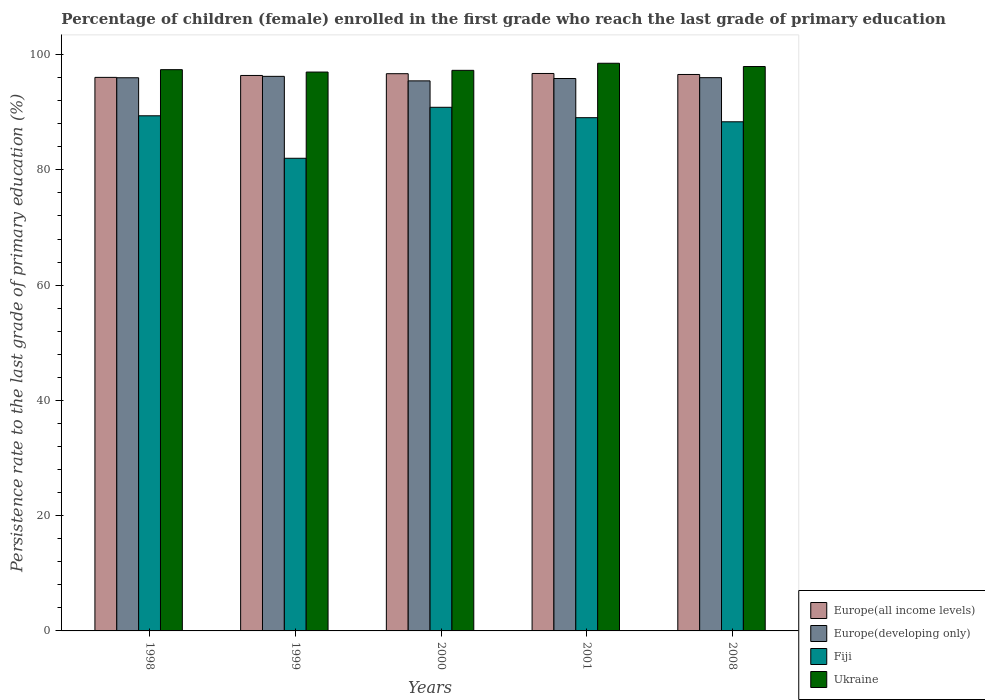Are the number of bars on each tick of the X-axis equal?
Your answer should be very brief. Yes. How many bars are there on the 1st tick from the left?
Provide a succinct answer. 4. What is the label of the 2nd group of bars from the left?
Provide a succinct answer. 1999. In how many cases, is the number of bars for a given year not equal to the number of legend labels?
Provide a short and direct response. 0. What is the persistence rate of children in Europe(all income levels) in 1998?
Offer a terse response. 96.04. Across all years, what is the maximum persistence rate of children in Ukraine?
Make the answer very short. 98.49. Across all years, what is the minimum persistence rate of children in Fiji?
Offer a terse response. 82.01. What is the total persistence rate of children in Europe(developing only) in the graph?
Ensure brevity in your answer.  479.48. What is the difference between the persistence rate of children in Fiji in 2000 and that in 2008?
Keep it short and to the point. 2.51. What is the difference between the persistence rate of children in Europe(all income levels) in 2008 and the persistence rate of children in Europe(developing only) in 1998?
Keep it short and to the point. 0.57. What is the average persistence rate of children in Fiji per year?
Your answer should be compact. 87.93. In the year 2008, what is the difference between the persistence rate of children in Fiji and persistence rate of children in Europe(developing only)?
Offer a very short reply. -7.65. What is the ratio of the persistence rate of children in Europe(all income levels) in 2000 to that in 2001?
Your response must be concise. 1. Is the persistence rate of children in Europe(developing only) in 2001 less than that in 2008?
Your answer should be very brief. Yes. What is the difference between the highest and the second highest persistence rate of children in Europe(all income levels)?
Your answer should be very brief. 0.04. What is the difference between the highest and the lowest persistence rate of children in Europe(developing only)?
Provide a short and direct response. 0.78. Is it the case that in every year, the sum of the persistence rate of children in Fiji and persistence rate of children in Ukraine is greater than the sum of persistence rate of children in Europe(developing only) and persistence rate of children in Europe(all income levels)?
Ensure brevity in your answer.  No. What does the 2nd bar from the left in 1998 represents?
Make the answer very short. Europe(developing only). What does the 3rd bar from the right in 2001 represents?
Make the answer very short. Europe(developing only). Is it the case that in every year, the sum of the persistence rate of children in Ukraine and persistence rate of children in Europe(all income levels) is greater than the persistence rate of children in Europe(developing only)?
Your response must be concise. Yes. How many bars are there?
Offer a very short reply. 20. How many years are there in the graph?
Provide a short and direct response. 5. What is the difference between two consecutive major ticks on the Y-axis?
Provide a short and direct response. 20. Are the values on the major ticks of Y-axis written in scientific E-notation?
Your response must be concise. No. Does the graph contain grids?
Offer a terse response. No. Where does the legend appear in the graph?
Offer a very short reply. Bottom right. How are the legend labels stacked?
Ensure brevity in your answer.  Vertical. What is the title of the graph?
Offer a very short reply. Percentage of children (female) enrolled in the first grade who reach the last grade of primary education. What is the label or title of the X-axis?
Make the answer very short. Years. What is the label or title of the Y-axis?
Make the answer very short. Persistence rate to the last grade of primary education (%). What is the Persistence rate to the last grade of primary education (%) in Europe(all income levels) in 1998?
Provide a succinct answer. 96.04. What is the Persistence rate to the last grade of primary education (%) of Europe(developing only) in 1998?
Make the answer very short. 95.98. What is the Persistence rate to the last grade of primary education (%) in Fiji in 1998?
Your answer should be compact. 89.38. What is the Persistence rate to the last grade of primary education (%) of Ukraine in 1998?
Your answer should be compact. 97.38. What is the Persistence rate to the last grade of primary education (%) of Europe(all income levels) in 1999?
Ensure brevity in your answer.  96.38. What is the Persistence rate to the last grade of primary education (%) of Europe(developing only) in 1999?
Ensure brevity in your answer.  96.22. What is the Persistence rate to the last grade of primary education (%) of Fiji in 1999?
Your response must be concise. 82.01. What is the Persistence rate to the last grade of primary education (%) in Ukraine in 1999?
Provide a succinct answer. 96.97. What is the Persistence rate to the last grade of primary education (%) of Europe(all income levels) in 2000?
Offer a terse response. 96.68. What is the Persistence rate to the last grade of primary education (%) in Europe(developing only) in 2000?
Your response must be concise. 95.44. What is the Persistence rate to the last grade of primary education (%) of Fiji in 2000?
Keep it short and to the point. 90.85. What is the Persistence rate to the last grade of primary education (%) of Ukraine in 2000?
Ensure brevity in your answer.  97.27. What is the Persistence rate to the last grade of primary education (%) of Europe(all income levels) in 2001?
Offer a terse response. 96.72. What is the Persistence rate to the last grade of primary education (%) of Europe(developing only) in 2001?
Make the answer very short. 95.85. What is the Persistence rate to the last grade of primary education (%) in Fiji in 2001?
Your answer should be very brief. 89.05. What is the Persistence rate to the last grade of primary education (%) in Ukraine in 2001?
Your answer should be compact. 98.49. What is the Persistence rate to the last grade of primary education (%) of Europe(all income levels) in 2008?
Give a very brief answer. 96.55. What is the Persistence rate to the last grade of primary education (%) of Europe(developing only) in 2008?
Make the answer very short. 95.99. What is the Persistence rate to the last grade of primary education (%) in Fiji in 2008?
Make the answer very short. 88.34. What is the Persistence rate to the last grade of primary education (%) in Ukraine in 2008?
Make the answer very short. 97.93. Across all years, what is the maximum Persistence rate to the last grade of primary education (%) of Europe(all income levels)?
Your answer should be very brief. 96.72. Across all years, what is the maximum Persistence rate to the last grade of primary education (%) of Europe(developing only)?
Ensure brevity in your answer.  96.22. Across all years, what is the maximum Persistence rate to the last grade of primary education (%) in Fiji?
Ensure brevity in your answer.  90.85. Across all years, what is the maximum Persistence rate to the last grade of primary education (%) in Ukraine?
Ensure brevity in your answer.  98.49. Across all years, what is the minimum Persistence rate to the last grade of primary education (%) of Europe(all income levels)?
Provide a short and direct response. 96.04. Across all years, what is the minimum Persistence rate to the last grade of primary education (%) in Europe(developing only)?
Your answer should be very brief. 95.44. Across all years, what is the minimum Persistence rate to the last grade of primary education (%) of Fiji?
Your answer should be compact. 82.01. Across all years, what is the minimum Persistence rate to the last grade of primary education (%) in Ukraine?
Provide a succinct answer. 96.97. What is the total Persistence rate to the last grade of primary education (%) in Europe(all income levels) in the graph?
Provide a succinct answer. 482.37. What is the total Persistence rate to the last grade of primary education (%) of Europe(developing only) in the graph?
Ensure brevity in your answer.  479.48. What is the total Persistence rate to the last grade of primary education (%) of Fiji in the graph?
Provide a short and direct response. 439.63. What is the total Persistence rate to the last grade of primary education (%) of Ukraine in the graph?
Your response must be concise. 488.04. What is the difference between the Persistence rate to the last grade of primary education (%) of Europe(all income levels) in 1998 and that in 1999?
Make the answer very short. -0.33. What is the difference between the Persistence rate to the last grade of primary education (%) of Europe(developing only) in 1998 and that in 1999?
Keep it short and to the point. -0.24. What is the difference between the Persistence rate to the last grade of primary education (%) in Fiji in 1998 and that in 1999?
Your answer should be compact. 7.37. What is the difference between the Persistence rate to the last grade of primary education (%) of Ukraine in 1998 and that in 1999?
Your response must be concise. 0.41. What is the difference between the Persistence rate to the last grade of primary education (%) of Europe(all income levels) in 1998 and that in 2000?
Provide a succinct answer. -0.64. What is the difference between the Persistence rate to the last grade of primary education (%) of Europe(developing only) in 1998 and that in 2000?
Your answer should be very brief. 0.54. What is the difference between the Persistence rate to the last grade of primary education (%) in Fiji in 1998 and that in 2000?
Your answer should be very brief. -1.48. What is the difference between the Persistence rate to the last grade of primary education (%) of Ukraine in 1998 and that in 2000?
Give a very brief answer. 0.12. What is the difference between the Persistence rate to the last grade of primary education (%) of Europe(all income levels) in 1998 and that in 2001?
Ensure brevity in your answer.  -0.68. What is the difference between the Persistence rate to the last grade of primary education (%) in Europe(developing only) in 1998 and that in 2001?
Provide a short and direct response. 0.13. What is the difference between the Persistence rate to the last grade of primary education (%) in Fiji in 1998 and that in 2001?
Your answer should be compact. 0.33. What is the difference between the Persistence rate to the last grade of primary education (%) of Ukraine in 1998 and that in 2001?
Offer a very short reply. -1.11. What is the difference between the Persistence rate to the last grade of primary education (%) of Europe(all income levels) in 1998 and that in 2008?
Your answer should be compact. -0.5. What is the difference between the Persistence rate to the last grade of primary education (%) in Europe(developing only) in 1998 and that in 2008?
Provide a short and direct response. -0.02. What is the difference between the Persistence rate to the last grade of primary education (%) in Fiji in 1998 and that in 2008?
Ensure brevity in your answer.  1.04. What is the difference between the Persistence rate to the last grade of primary education (%) in Ukraine in 1998 and that in 2008?
Your answer should be compact. -0.54. What is the difference between the Persistence rate to the last grade of primary education (%) of Europe(all income levels) in 1999 and that in 2000?
Provide a short and direct response. -0.3. What is the difference between the Persistence rate to the last grade of primary education (%) in Europe(developing only) in 1999 and that in 2000?
Your response must be concise. 0.78. What is the difference between the Persistence rate to the last grade of primary education (%) in Fiji in 1999 and that in 2000?
Ensure brevity in your answer.  -8.85. What is the difference between the Persistence rate to the last grade of primary education (%) of Ukraine in 1999 and that in 2000?
Your response must be concise. -0.3. What is the difference between the Persistence rate to the last grade of primary education (%) of Europe(all income levels) in 1999 and that in 2001?
Ensure brevity in your answer.  -0.34. What is the difference between the Persistence rate to the last grade of primary education (%) of Europe(developing only) in 1999 and that in 2001?
Your answer should be very brief. 0.37. What is the difference between the Persistence rate to the last grade of primary education (%) of Fiji in 1999 and that in 2001?
Provide a short and direct response. -7.04. What is the difference between the Persistence rate to the last grade of primary education (%) in Ukraine in 1999 and that in 2001?
Provide a short and direct response. -1.53. What is the difference between the Persistence rate to the last grade of primary education (%) in Europe(all income levels) in 1999 and that in 2008?
Give a very brief answer. -0.17. What is the difference between the Persistence rate to the last grade of primary education (%) of Europe(developing only) in 1999 and that in 2008?
Your answer should be compact. 0.23. What is the difference between the Persistence rate to the last grade of primary education (%) in Fiji in 1999 and that in 2008?
Give a very brief answer. -6.33. What is the difference between the Persistence rate to the last grade of primary education (%) in Ukraine in 1999 and that in 2008?
Ensure brevity in your answer.  -0.96. What is the difference between the Persistence rate to the last grade of primary education (%) in Europe(all income levels) in 2000 and that in 2001?
Ensure brevity in your answer.  -0.04. What is the difference between the Persistence rate to the last grade of primary education (%) in Europe(developing only) in 2000 and that in 2001?
Give a very brief answer. -0.41. What is the difference between the Persistence rate to the last grade of primary education (%) in Fiji in 2000 and that in 2001?
Make the answer very short. 1.8. What is the difference between the Persistence rate to the last grade of primary education (%) of Ukraine in 2000 and that in 2001?
Your answer should be compact. -1.23. What is the difference between the Persistence rate to the last grade of primary education (%) of Europe(all income levels) in 2000 and that in 2008?
Provide a succinct answer. 0.14. What is the difference between the Persistence rate to the last grade of primary education (%) of Europe(developing only) in 2000 and that in 2008?
Your response must be concise. -0.56. What is the difference between the Persistence rate to the last grade of primary education (%) in Fiji in 2000 and that in 2008?
Provide a short and direct response. 2.51. What is the difference between the Persistence rate to the last grade of primary education (%) in Ukraine in 2000 and that in 2008?
Offer a very short reply. -0.66. What is the difference between the Persistence rate to the last grade of primary education (%) of Europe(all income levels) in 2001 and that in 2008?
Provide a short and direct response. 0.17. What is the difference between the Persistence rate to the last grade of primary education (%) of Europe(developing only) in 2001 and that in 2008?
Ensure brevity in your answer.  -0.15. What is the difference between the Persistence rate to the last grade of primary education (%) in Fiji in 2001 and that in 2008?
Give a very brief answer. 0.71. What is the difference between the Persistence rate to the last grade of primary education (%) of Ukraine in 2001 and that in 2008?
Offer a very short reply. 0.57. What is the difference between the Persistence rate to the last grade of primary education (%) in Europe(all income levels) in 1998 and the Persistence rate to the last grade of primary education (%) in Europe(developing only) in 1999?
Provide a succinct answer. -0.18. What is the difference between the Persistence rate to the last grade of primary education (%) in Europe(all income levels) in 1998 and the Persistence rate to the last grade of primary education (%) in Fiji in 1999?
Offer a terse response. 14.04. What is the difference between the Persistence rate to the last grade of primary education (%) of Europe(all income levels) in 1998 and the Persistence rate to the last grade of primary education (%) of Ukraine in 1999?
Your answer should be compact. -0.93. What is the difference between the Persistence rate to the last grade of primary education (%) in Europe(developing only) in 1998 and the Persistence rate to the last grade of primary education (%) in Fiji in 1999?
Give a very brief answer. 13.97. What is the difference between the Persistence rate to the last grade of primary education (%) in Europe(developing only) in 1998 and the Persistence rate to the last grade of primary education (%) in Ukraine in 1999?
Offer a terse response. -0.99. What is the difference between the Persistence rate to the last grade of primary education (%) of Fiji in 1998 and the Persistence rate to the last grade of primary education (%) of Ukraine in 1999?
Provide a succinct answer. -7.59. What is the difference between the Persistence rate to the last grade of primary education (%) in Europe(all income levels) in 1998 and the Persistence rate to the last grade of primary education (%) in Europe(developing only) in 2000?
Offer a very short reply. 0.61. What is the difference between the Persistence rate to the last grade of primary education (%) in Europe(all income levels) in 1998 and the Persistence rate to the last grade of primary education (%) in Fiji in 2000?
Offer a very short reply. 5.19. What is the difference between the Persistence rate to the last grade of primary education (%) of Europe(all income levels) in 1998 and the Persistence rate to the last grade of primary education (%) of Ukraine in 2000?
Offer a very short reply. -1.22. What is the difference between the Persistence rate to the last grade of primary education (%) in Europe(developing only) in 1998 and the Persistence rate to the last grade of primary education (%) in Fiji in 2000?
Offer a terse response. 5.12. What is the difference between the Persistence rate to the last grade of primary education (%) in Europe(developing only) in 1998 and the Persistence rate to the last grade of primary education (%) in Ukraine in 2000?
Ensure brevity in your answer.  -1.29. What is the difference between the Persistence rate to the last grade of primary education (%) in Fiji in 1998 and the Persistence rate to the last grade of primary education (%) in Ukraine in 2000?
Offer a very short reply. -7.89. What is the difference between the Persistence rate to the last grade of primary education (%) of Europe(all income levels) in 1998 and the Persistence rate to the last grade of primary education (%) of Europe(developing only) in 2001?
Ensure brevity in your answer.  0.2. What is the difference between the Persistence rate to the last grade of primary education (%) in Europe(all income levels) in 1998 and the Persistence rate to the last grade of primary education (%) in Fiji in 2001?
Provide a succinct answer. 6.99. What is the difference between the Persistence rate to the last grade of primary education (%) of Europe(all income levels) in 1998 and the Persistence rate to the last grade of primary education (%) of Ukraine in 2001?
Your answer should be compact. -2.45. What is the difference between the Persistence rate to the last grade of primary education (%) in Europe(developing only) in 1998 and the Persistence rate to the last grade of primary education (%) in Fiji in 2001?
Keep it short and to the point. 6.93. What is the difference between the Persistence rate to the last grade of primary education (%) of Europe(developing only) in 1998 and the Persistence rate to the last grade of primary education (%) of Ukraine in 2001?
Offer a very short reply. -2.52. What is the difference between the Persistence rate to the last grade of primary education (%) in Fiji in 1998 and the Persistence rate to the last grade of primary education (%) in Ukraine in 2001?
Your response must be concise. -9.12. What is the difference between the Persistence rate to the last grade of primary education (%) of Europe(all income levels) in 1998 and the Persistence rate to the last grade of primary education (%) of Europe(developing only) in 2008?
Give a very brief answer. 0.05. What is the difference between the Persistence rate to the last grade of primary education (%) in Europe(all income levels) in 1998 and the Persistence rate to the last grade of primary education (%) in Fiji in 2008?
Your answer should be compact. 7.7. What is the difference between the Persistence rate to the last grade of primary education (%) in Europe(all income levels) in 1998 and the Persistence rate to the last grade of primary education (%) in Ukraine in 2008?
Your answer should be very brief. -1.88. What is the difference between the Persistence rate to the last grade of primary education (%) in Europe(developing only) in 1998 and the Persistence rate to the last grade of primary education (%) in Fiji in 2008?
Keep it short and to the point. 7.64. What is the difference between the Persistence rate to the last grade of primary education (%) of Europe(developing only) in 1998 and the Persistence rate to the last grade of primary education (%) of Ukraine in 2008?
Offer a very short reply. -1.95. What is the difference between the Persistence rate to the last grade of primary education (%) in Fiji in 1998 and the Persistence rate to the last grade of primary education (%) in Ukraine in 2008?
Make the answer very short. -8.55. What is the difference between the Persistence rate to the last grade of primary education (%) of Europe(all income levels) in 1999 and the Persistence rate to the last grade of primary education (%) of Europe(developing only) in 2000?
Provide a succinct answer. 0.94. What is the difference between the Persistence rate to the last grade of primary education (%) of Europe(all income levels) in 1999 and the Persistence rate to the last grade of primary education (%) of Fiji in 2000?
Ensure brevity in your answer.  5.52. What is the difference between the Persistence rate to the last grade of primary education (%) of Europe(all income levels) in 1999 and the Persistence rate to the last grade of primary education (%) of Ukraine in 2000?
Make the answer very short. -0.89. What is the difference between the Persistence rate to the last grade of primary education (%) in Europe(developing only) in 1999 and the Persistence rate to the last grade of primary education (%) in Fiji in 2000?
Keep it short and to the point. 5.37. What is the difference between the Persistence rate to the last grade of primary education (%) of Europe(developing only) in 1999 and the Persistence rate to the last grade of primary education (%) of Ukraine in 2000?
Give a very brief answer. -1.05. What is the difference between the Persistence rate to the last grade of primary education (%) in Fiji in 1999 and the Persistence rate to the last grade of primary education (%) in Ukraine in 2000?
Provide a short and direct response. -15.26. What is the difference between the Persistence rate to the last grade of primary education (%) of Europe(all income levels) in 1999 and the Persistence rate to the last grade of primary education (%) of Europe(developing only) in 2001?
Your answer should be compact. 0.53. What is the difference between the Persistence rate to the last grade of primary education (%) of Europe(all income levels) in 1999 and the Persistence rate to the last grade of primary education (%) of Fiji in 2001?
Your response must be concise. 7.33. What is the difference between the Persistence rate to the last grade of primary education (%) in Europe(all income levels) in 1999 and the Persistence rate to the last grade of primary education (%) in Ukraine in 2001?
Make the answer very short. -2.12. What is the difference between the Persistence rate to the last grade of primary education (%) of Europe(developing only) in 1999 and the Persistence rate to the last grade of primary education (%) of Fiji in 2001?
Offer a terse response. 7.17. What is the difference between the Persistence rate to the last grade of primary education (%) of Europe(developing only) in 1999 and the Persistence rate to the last grade of primary education (%) of Ukraine in 2001?
Your answer should be very brief. -2.27. What is the difference between the Persistence rate to the last grade of primary education (%) in Fiji in 1999 and the Persistence rate to the last grade of primary education (%) in Ukraine in 2001?
Your response must be concise. -16.49. What is the difference between the Persistence rate to the last grade of primary education (%) of Europe(all income levels) in 1999 and the Persistence rate to the last grade of primary education (%) of Europe(developing only) in 2008?
Your response must be concise. 0.38. What is the difference between the Persistence rate to the last grade of primary education (%) of Europe(all income levels) in 1999 and the Persistence rate to the last grade of primary education (%) of Fiji in 2008?
Make the answer very short. 8.04. What is the difference between the Persistence rate to the last grade of primary education (%) of Europe(all income levels) in 1999 and the Persistence rate to the last grade of primary education (%) of Ukraine in 2008?
Make the answer very short. -1.55. What is the difference between the Persistence rate to the last grade of primary education (%) in Europe(developing only) in 1999 and the Persistence rate to the last grade of primary education (%) in Fiji in 2008?
Ensure brevity in your answer.  7.88. What is the difference between the Persistence rate to the last grade of primary education (%) of Europe(developing only) in 1999 and the Persistence rate to the last grade of primary education (%) of Ukraine in 2008?
Make the answer very short. -1.71. What is the difference between the Persistence rate to the last grade of primary education (%) in Fiji in 1999 and the Persistence rate to the last grade of primary education (%) in Ukraine in 2008?
Provide a short and direct response. -15.92. What is the difference between the Persistence rate to the last grade of primary education (%) of Europe(all income levels) in 2000 and the Persistence rate to the last grade of primary education (%) of Europe(developing only) in 2001?
Ensure brevity in your answer.  0.84. What is the difference between the Persistence rate to the last grade of primary education (%) of Europe(all income levels) in 2000 and the Persistence rate to the last grade of primary education (%) of Fiji in 2001?
Provide a short and direct response. 7.63. What is the difference between the Persistence rate to the last grade of primary education (%) of Europe(all income levels) in 2000 and the Persistence rate to the last grade of primary education (%) of Ukraine in 2001?
Make the answer very short. -1.81. What is the difference between the Persistence rate to the last grade of primary education (%) of Europe(developing only) in 2000 and the Persistence rate to the last grade of primary education (%) of Fiji in 2001?
Your answer should be compact. 6.39. What is the difference between the Persistence rate to the last grade of primary education (%) of Europe(developing only) in 2000 and the Persistence rate to the last grade of primary education (%) of Ukraine in 2001?
Keep it short and to the point. -3.06. What is the difference between the Persistence rate to the last grade of primary education (%) in Fiji in 2000 and the Persistence rate to the last grade of primary education (%) in Ukraine in 2001?
Give a very brief answer. -7.64. What is the difference between the Persistence rate to the last grade of primary education (%) of Europe(all income levels) in 2000 and the Persistence rate to the last grade of primary education (%) of Europe(developing only) in 2008?
Your answer should be compact. 0.69. What is the difference between the Persistence rate to the last grade of primary education (%) in Europe(all income levels) in 2000 and the Persistence rate to the last grade of primary education (%) in Fiji in 2008?
Your answer should be compact. 8.34. What is the difference between the Persistence rate to the last grade of primary education (%) of Europe(all income levels) in 2000 and the Persistence rate to the last grade of primary education (%) of Ukraine in 2008?
Provide a succinct answer. -1.24. What is the difference between the Persistence rate to the last grade of primary education (%) in Europe(developing only) in 2000 and the Persistence rate to the last grade of primary education (%) in Fiji in 2008?
Your answer should be very brief. 7.1. What is the difference between the Persistence rate to the last grade of primary education (%) of Europe(developing only) in 2000 and the Persistence rate to the last grade of primary education (%) of Ukraine in 2008?
Your response must be concise. -2.49. What is the difference between the Persistence rate to the last grade of primary education (%) in Fiji in 2000 and the Persistence rate to the last grade of primary education (%) in Ukraine in 2008?
Offer a terse response. -7.07. What is the difference between the Persistence rate to the last grade of primary education (%) of Europe(all income levels) in 2001 and the Persistence rate to the last grade of primary education (%) of Europe(developing only) in 2008?
Ensure brevity in your answer.  0.73. What is the difference between the Persistence rate to the last grade of primary education (%) in Europe(all income levels) in 2001 and the Persistence rate to the last grade of primary education (%) in Fiji in 2008?
Offer a terse response. 8.38. What is the difference between the Persistence rate to the last grade of primary education (%) of Europe(all income levels) in 2001 and the Persistence rate to the last grade of primary education (%) of Ukraine in 2008?
Offer a terse response. -1.2. What is the difference between the Persistence rate to the last grade of primary education (%) in Europe(developing only) in 2001 and the Persistence rate to the last grade of primary education (%) in Fiji in 2008?
Ensure brevity in your answer.  7.51. What is the difference between the Persistence rate to the last grade of primary education (%) in Europe(developing only) in 2001 and the Persistence rate to the last grade of primary education (%) in Ukraine in 2008?
Provide a succinct answer. -2.08. What is the difference between the Persistence rate to the last grade of primary education (%) in Fiji in 2001 and the Persistence rate to the last grade of primary education (%) in Ukraine in 2008?
Offer a very short reply. -8.88. What is the average Persistence rate to the last grade of primary education (%) in Europe(all income levels) per year?
Provide a succinct answer. 96.47. What is the average Persistence rate to the last grade of primary education (%) in Europe(developing only) per year?
Your answer should be compact. 95.9. What is the average Persistence rate to the last grade of primary education (%) of Fiji per year?
Keep it short and to the point. 87.93. What is the average Persistence rate to the last grade of primary education (%) of Ukraine per year?
Provide a short and direct response. 97.61. In the year 1998, what is the difference between the Persistence rate to the last grade of primary education (%) of Europe(all income levels) and Persistence rate to the last grade of primary education (%) of Europe(developing only)?
Make the answer very short. 0.06. In the year 1998, what is the difference between the Persistence rate to the last grade of primary education (%) of Europe(all income levels) and Persistence rate to the last grade of primary education (%) of Fiji?
Your answer should be very brief. 6.66. In the year 1998, what is the difference between the Persistence rate to the last grade of primary education (%) in Europe(all income levels) and Persistence rate to the last grade of primary education (%) in Ukraine?
Make the answer very short. -1.34. In the year 1998, what is the difference between the Persistence rate to the last grade of primary education (%) of Europe(developing only) and Persistence rate to the last grade of primary education (%) of Fiji?
Offer a terse response. 6.6. In the year 1998, what is the difference between the Persistence rate to the last grade of primary education (%) of Europe(developing only) and Persistence rate to the last grade of primary education (%) of Ukraine?
Offer a terse response. -1.4. In the year 1998, what is the difference between the Persistence rate to the last grade of primary education (%) in Fiji and Persistence rate to the last grade of primary education (%) in Ukraine?
Ensure brevity in your answer.  -8. In the year 1999, what is the difference between the Persistence rate to the last grade of primary education (%) in Europe(all income levels) and Persistence rate to the last grade of primary education (%) in Europe(developing only)?
Offer a terse response. 0.16. In the year 1999, what is the difference between the Persistence rate to the last grade of primary education (%) of Europe(all income levels) and Persistence rate to the last grade of primary education (%) of Fiji?
Provide a short and direct response. 14.37. In the year 1999, what is the difference between the Persistence rate to the last grade of primary education (%) in Europe(all income levels) and Persistence rate to the last grade of primary education (%) in Ukraine?
Your answer should be compact. -0.59. In the year 1999, what is the difference between the Persistence rate to the last grade of primary education (%) in Europe(developing only) and Persistence rate to the last grade of primary education (%) in Fiji?
Your answer should be compact. 14.21. In the year 1999, what is the difference between the Persistence rate to the last grade of primary education (%) of Europe(developing only) and Persistence rate to the last grade of primary education (%) of Ukraine?
Offer a very short reply. -0.75. In the year 1999, what is the difference between the Persistence rate to the last grade of primary education (%) of Fiji and Persistence rate to the last grade of primary education (%) of Ukraine?
Your answer should be very brief. -14.96. In the year 2000, what is the difference between the Persistence rate to the last grade of primary education (%) of Europe(all income levels) and Persistence rate to the last grade of primary education (%) of Europe(developing only)?
Keep it short and to the point. 1.25. In the year 2000, what is the difference between the Persistence rate to the last grade of primary education (%) in Europe(all income levels) and Persistence rate to the last grade of primary education (%) in Fiji?
Your response must be concise. 5.83. In the year 2000, what is the difference between the Persistence rate to the last grade of primary education (%) in Europe(all income levels) and Persistence rate to the last grade of primary education (%) in Ukraine?
Make the answer very short. -0.58. In the year 2000, what is the difference between the Persistence rate to the last grade of primary education (%) of Europe(developing only) and Persistence rate to the last grade of primary education (%) of Fiji?
Your answer should be very brief. 4.58. In the year 2000, what is the difference between the Persistence rate to the last grade of primary education (%) of Europe(developing only) and Persistence rate to the last grade of primary education (%) of Ukraine?
Give a very brief answer. -1.83. In the year 2000, what is the difference between the Persistence rate to the last grade of primary education (%) in Fiji and Persistence rate to the last grade of primary education (%) in Ukraine?
Offer a terse response. -6.41. In the year 2001, what is the difference between the Persistence rate to the last grade of primary education (%) in Europe(all income levels) and Persistence rate to the last grade of primary education (%) in Europe(developing only)?
Your answer should be compact. 0.87. In the year 2001, what is the difference between the Persistence rate to the last grade of primary education (%) in Europe(all income levels) and Persistence rate to the last grade of primary education (%) in Fiji?
Offer a terse response. 7.67. In the year 2001, what is the difference between the Persistence rate to the last grade of primary education (%) in Europe(all income levels) and Persistence rate to the last grade of primary education (%) in Ukraine?
Offer a terse response. -1.77. In the year 2001, what is the difference between the Persistence rate to the last grade of primary education (%) in Europe(developing only) and Persistence rate to the last grade of primary education (%) in Fiji?
Provide a succinct answer. 6.8. In the year 2001, what is the difference between the Persistence rate to the last grade of primary education (%) in Europe(developing only) and Persistence rate to the last grade of primary education (%) in Ukraine?
Offer a terse response. -2.65. In the year 2001, what is the difference between the Persistence rate to the last grade of primary education (%) in Fiji and Persistence rate to the last grade of primary education (%) in Ukraine?
Make the answer very short. -9.44. In the year 2008, what is the difference between the Persistence rate to the last grade of primary education (%) of Europe(all income levels) and Persistence rate to the last grade of primary education (%) of Europe(developing only)?
Your response must be concise. 0.55. In the year 2008, what is the difference between the Persistence rate to the last grade of primary education (%) of Europe(all income levels) and Persistence rate to the last grade of primary education (%) of Fiji?
Keep it short and to the point. 8.21. In the year 2008, what is the difference between the Persistence rate to the last grade of primary education (%) in Europe(all income levels) and Persistence rate to the last grade of primary education (%) in Ukraine?
Your response must be concise. -1.38. In the year 2008, what is the difference between the Persistence rate to the last grade of primary education (%) of Europe(developing only) and Persistence rate to the last grade of primary education (%) of Fiji?
Provide a short and direct response. 7.65. In the year 2008, what is the difference between the Persistence rate to the last grade of primary education (%) in Europe(developing only) and Persistence rate to the last grade of primary education (%) in Ukraine?
Provide a succinct answer. -1.93. In the year 2008, what is the difference between the Persistence rate to the last grade of primary education (%) of Fiji and Persistence rate to the last grade of primary education (%) of Ukraine?
Provide a succinct answer. -9.59. What is the ratio of the Persistence rate to the last grade of primary education (%) of Fiji in 1998 to that in 1999?
Make the answer very short. 1.09. What is the ratio of the Persistence rate to the last grade of primary education (%) in Europe(developing only) in 1998 to that in 2000?
Keep it short and to the point. 1.01. What is the ratio of the Persistence rate to the last grade of primary education (%) in Fiji in 1998 to that in 2000?
Your response must be concise. 0.98. What is the ratio of the Persistence rate to the last grade of primary education (%) of Ukraine in 1998 to that in 2000?
Keep it short and to the point. 1. What is the ratio of the Persistence rate to the last grade of primary education (%) of Europe(all income levels) in 1998 to that in 2001?
Make the answer very short. 0.99. What is the ratio of the Persistence rate to the last grade of primary education (%) of Europe(developing only) in 1998 to that in 2001?
Your answer should be compact. 1. What is the ratio of the Persistence rate to the last grade of primary education (%) in Ukraine in 1998 to that in 2001?
Provide a short and direct response. 0.99. What is the ratio of the Persistence rate to the last grade of primary education (%) in Fiji in 1998 to that in 2008?
Your answer should be very brief. 1.01. What is the ratio of the Persistence rate to the last grade of primary education (%) of Europe(all income levels) in 1999 to that in 2000?
Your answer should be very brief. 1. What is the ratio of the Persistence rate to the last grade of primary education (%) of Europe(developing only) in 1999 to that in 2000?
Make the answer very short. 1.01. What is the ratio of the Persistence rate to the last grade of primary education (%) of Fiji in 1999 to that in 2000?
Provide a succinct answer. 0.9. What is the ratio of the Persistence rate to the last grade of primary education (%) in Ukraine in 1999 to that in 2000?
Provide a short and direct response. 1. What is the ratio of the Persistence rate to the last grade of primary education (%) in Europe(all income levels) in 1999 to that in 2001?
Offer a terse response. 1. What is the ratio of the Persistence rate to the last grade of primary education (%) of Europe(developing only) in 1999 to that in 2001?
Your answer should be compact. 1. What is the ratio of the Persistence rate to the last grade of primary education (%) in Fiji in 1999 to that in 2001?
Make the answer very short. 0.92. What is the ratio of the Persistence rate to the last grade of primary education (%) of Ukraine in 1999 to that in 2001?
Offer a very short reply. 0.98. What is the ratio of the Persistence rate to the last grade of primary education (%) of Europe(developing only) in 1999 to that in 2008?
Provide a succinct answer. 1. What is the ratio of the Persistence rate to the last grade of primary education (%) of Fiji in 1999 to that in 2008?
Provide a short and direct response. 0.93. What is the ratio of the Persistence rate to the last grade of primary education (%) of Ukraine in 1999 to that in 2008?
Give a very brief answer. 0.99. What is the ratio of the Persistence rate to the last grade of primary education (%) in Europe(developing only) in 2000 to that in 2001?
Your answer should be very brief. 1. What is the ratio of the Persistence rate to the last grade of primary education (%) of Fiji in 2000 to that in 2001?
Give a very brief answer. 1.02. What is the ratio of the Persistence rate to the last grade of primary education (%) in Ukraine in 2000 to that in 2001?
Keep it short and to the point. 0.99. What is the ratio of the Persistence rate to the last grade of primary education (%) in Europe(all income levels) in 2000 to that in 2008?
Your answer should be compact. 1. What is the ratio of the Persistence rate to the last grade of primary education (%) in Europe(developing only) in 2000 to that in 2008?
Ensure brevity in your answer.  0.99. What is the ratio of the Persistence rate to the last grade of primary education (%) in Fiji in 2000 to that in 2008?
Your answer should be very brief. 1.03. What is the ratio of the Persistence rate to the last grade of primary education (%) of Europe(all income levels) in 2001 to that in 2008?
Ensure brevity in your answer.  1. What is the ratio of the Persistence rate to the last grade of primary education (%) in Europe(developing only) in 2001 to that in 2008?
Keep it short and to the point. 1. What is the ratio of the Persistence rate to the last grade of primary education (%) of Fiji in 2001 to that in 2008?
Your response must be concise. 1.01. What is the ratio of the Persistence rate to the last grade of primary education (%) of Ukraine in 2001 to that in 2008?
Make the answer very short. 1.01. What is the difference between the highest and the second highest Persistence rate to the last grade of primary education (%) in Europe(all income levels)?
Keep it short and to the point. 0.04. What is the difference between the highest and the second highest Persistence rate to the last grade of primary education (%) in Europe(developing only)?
Your answer should be very brief. 0.23. What is the difference between the highest and the second highest Persistence rate to the last grade of primary education (%) in Fiji?
Your answer should be compact. 1.48. What is the difference between the highest and the second highest Persistence rate to the last grade of primary education (%) in Ukraine?
Your response must be concise. 0.57. What is the difference between the highest and the lowest Persistence rate to the last grade of primary education (%) in Europe(all income levels)?
Offer a very short reply. 0.68. What is the difference between the highest and the lowest Persistence rate to the last grade of primary education (%) of Europe(developing only)?
Provide a short and direct response. 0.78. What is the difference between the highest and the lowest Persistence rate to the last grade of primary education (%) in Fiji?
Offer a very short reply. 8.85. What is the difference between the highest and the lowest Persistence rate to the last grade of primary education (%) of Ukraine?
Your answer should be compact. 1.53. 